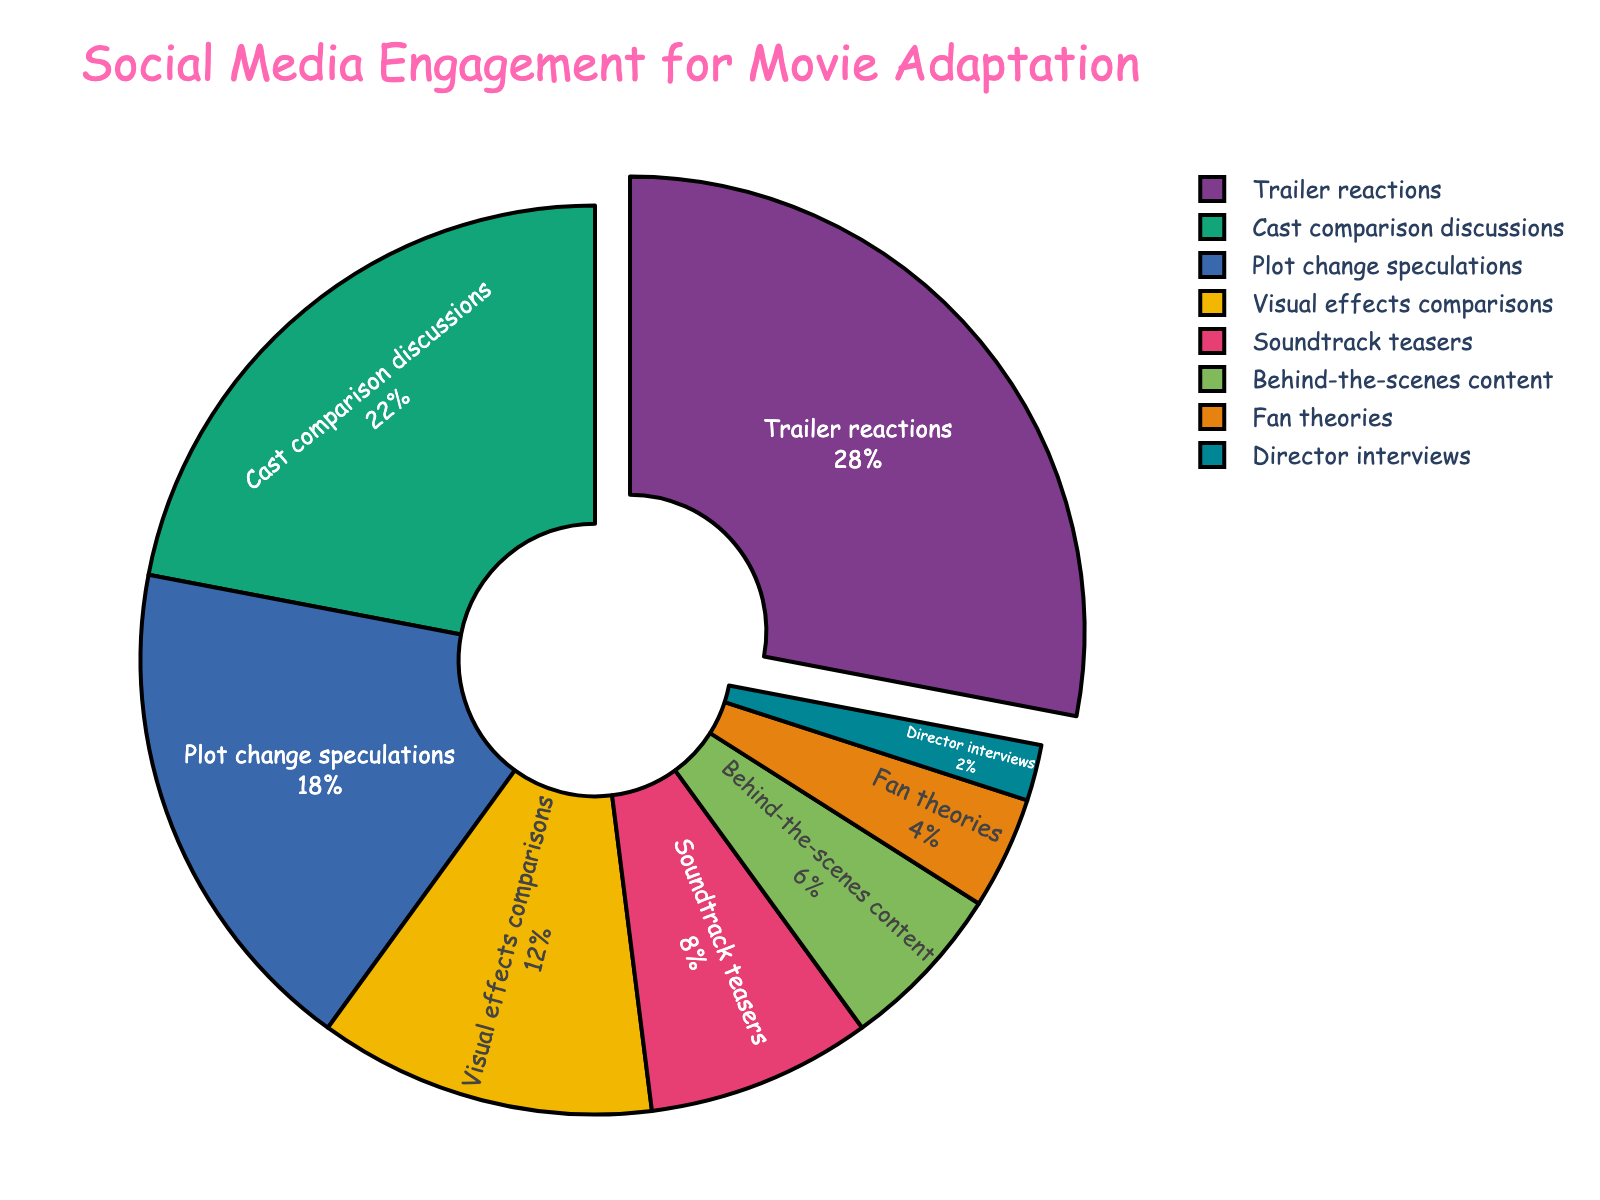what percentage of social media engagement is dedicated to Fan theories? The pie chart shows different aspects and their corresponding percentages of social media engagement. From the chart, we see that Fan theories occupy 4% of the engagement.
Answer: 4% How much more engagement do Trailer reactions receive compared to Director interviews? The percentage engagement for Trailer reactions is 28%, while Director interviews get 2%. The difference between them is 28% - 2% = 26%.
Answer: 26% What is the sum of the percentages for Behind-the-scenes content and Soundtrack teasers? Behind-the-scenes content has 6% engagement, and Soundtrack teasers have 8% engagement. Adding them together, 6% + 8% = 14%.
Answer: 14% Which aspect has the highest social media engagement? Looking at the pie chart, the section with the largest percentage is for Trailer reactions at 28%.
Answer: Trailer reactions Are Cast comparison discussions more engaged than Plot change speculations? Cast comparison discussions have a 22% engagement, while Plot change speculations have an 18% engagement. Since 22% > 18%, Cast comparison discussions are more engaged.
Answer: Yes How does the engagement for Visual effects comparisons compare to the engagement for the Soundtrack teasers and Fan theories combined? Visual effects comparisons have 12% engagement. Soundtrack teasers have 8%, and Fan theories have 4%. Combining these two gives 8% + 4% = 12%. Since 12% = 12%, they have the same engagement.
Answer: Equal Which aspect related to the movie adaptation has the least engagement? The smallest segment in the pie chart corresponds to Director interviews, which has 2% engagement.
Answer: Director interviews If you combine the engagements for Plot change speculations, Soundtrack teasers, and Director interviews, what is the total percentage? Plot change speculations have 18%, Soundtrack teasers have 8%, and Director interviews have 2%. Summing these up, we get 18% + 8% + 2% = 28%.
Answer: 28% What is the median percentage value of the different aspects' engagement? The percentages in ascending order are 2%, 4%, 6%, 8%, 12%, 18%, 22%, 28%. Since there are 8 values, the median is the average of the 4th and 5th values. So, median = (8% + 12%)/2 = 10%.
Answer: 10% Which aspects of social media engagement are highlighted or stand out visually? The pie chart visually emphasizes the aspect with the highest percentage, Trailer reactions, by pulling it out from the rest of the chart.
Answer: Trailer reactions 